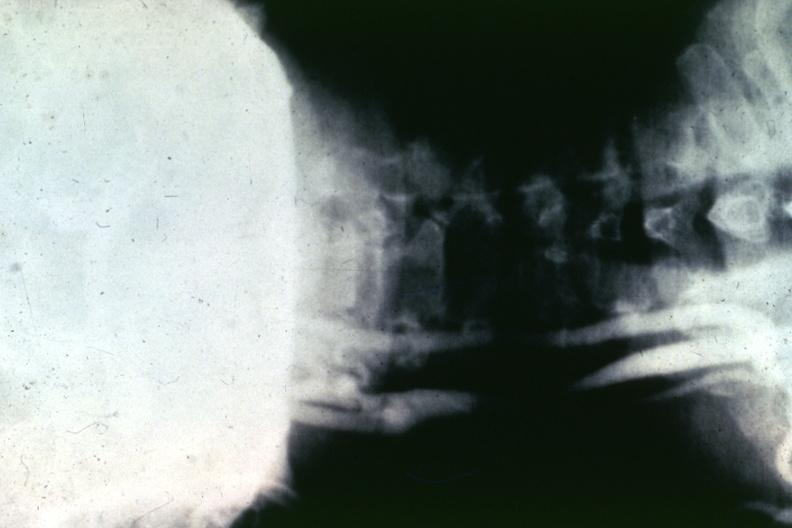what is present?
Answer the question using a single word or phrase. Cardiovascular 